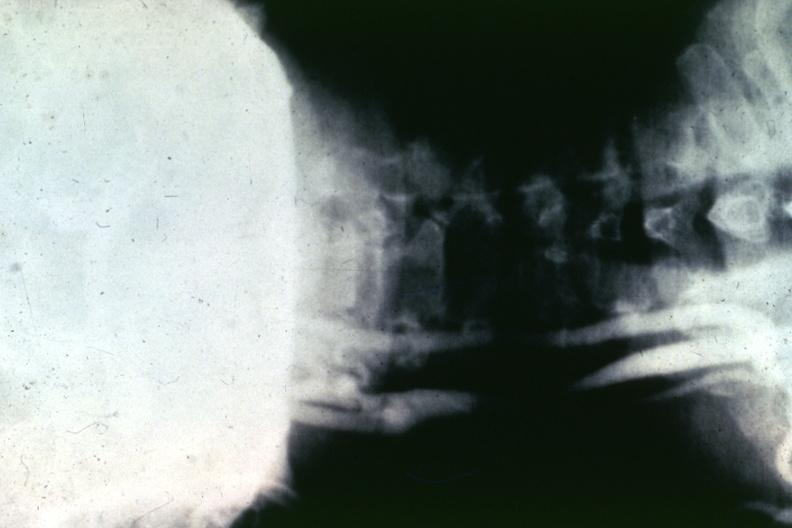what is present?
Answer the question using a single word or phrase. Cardiovascular 